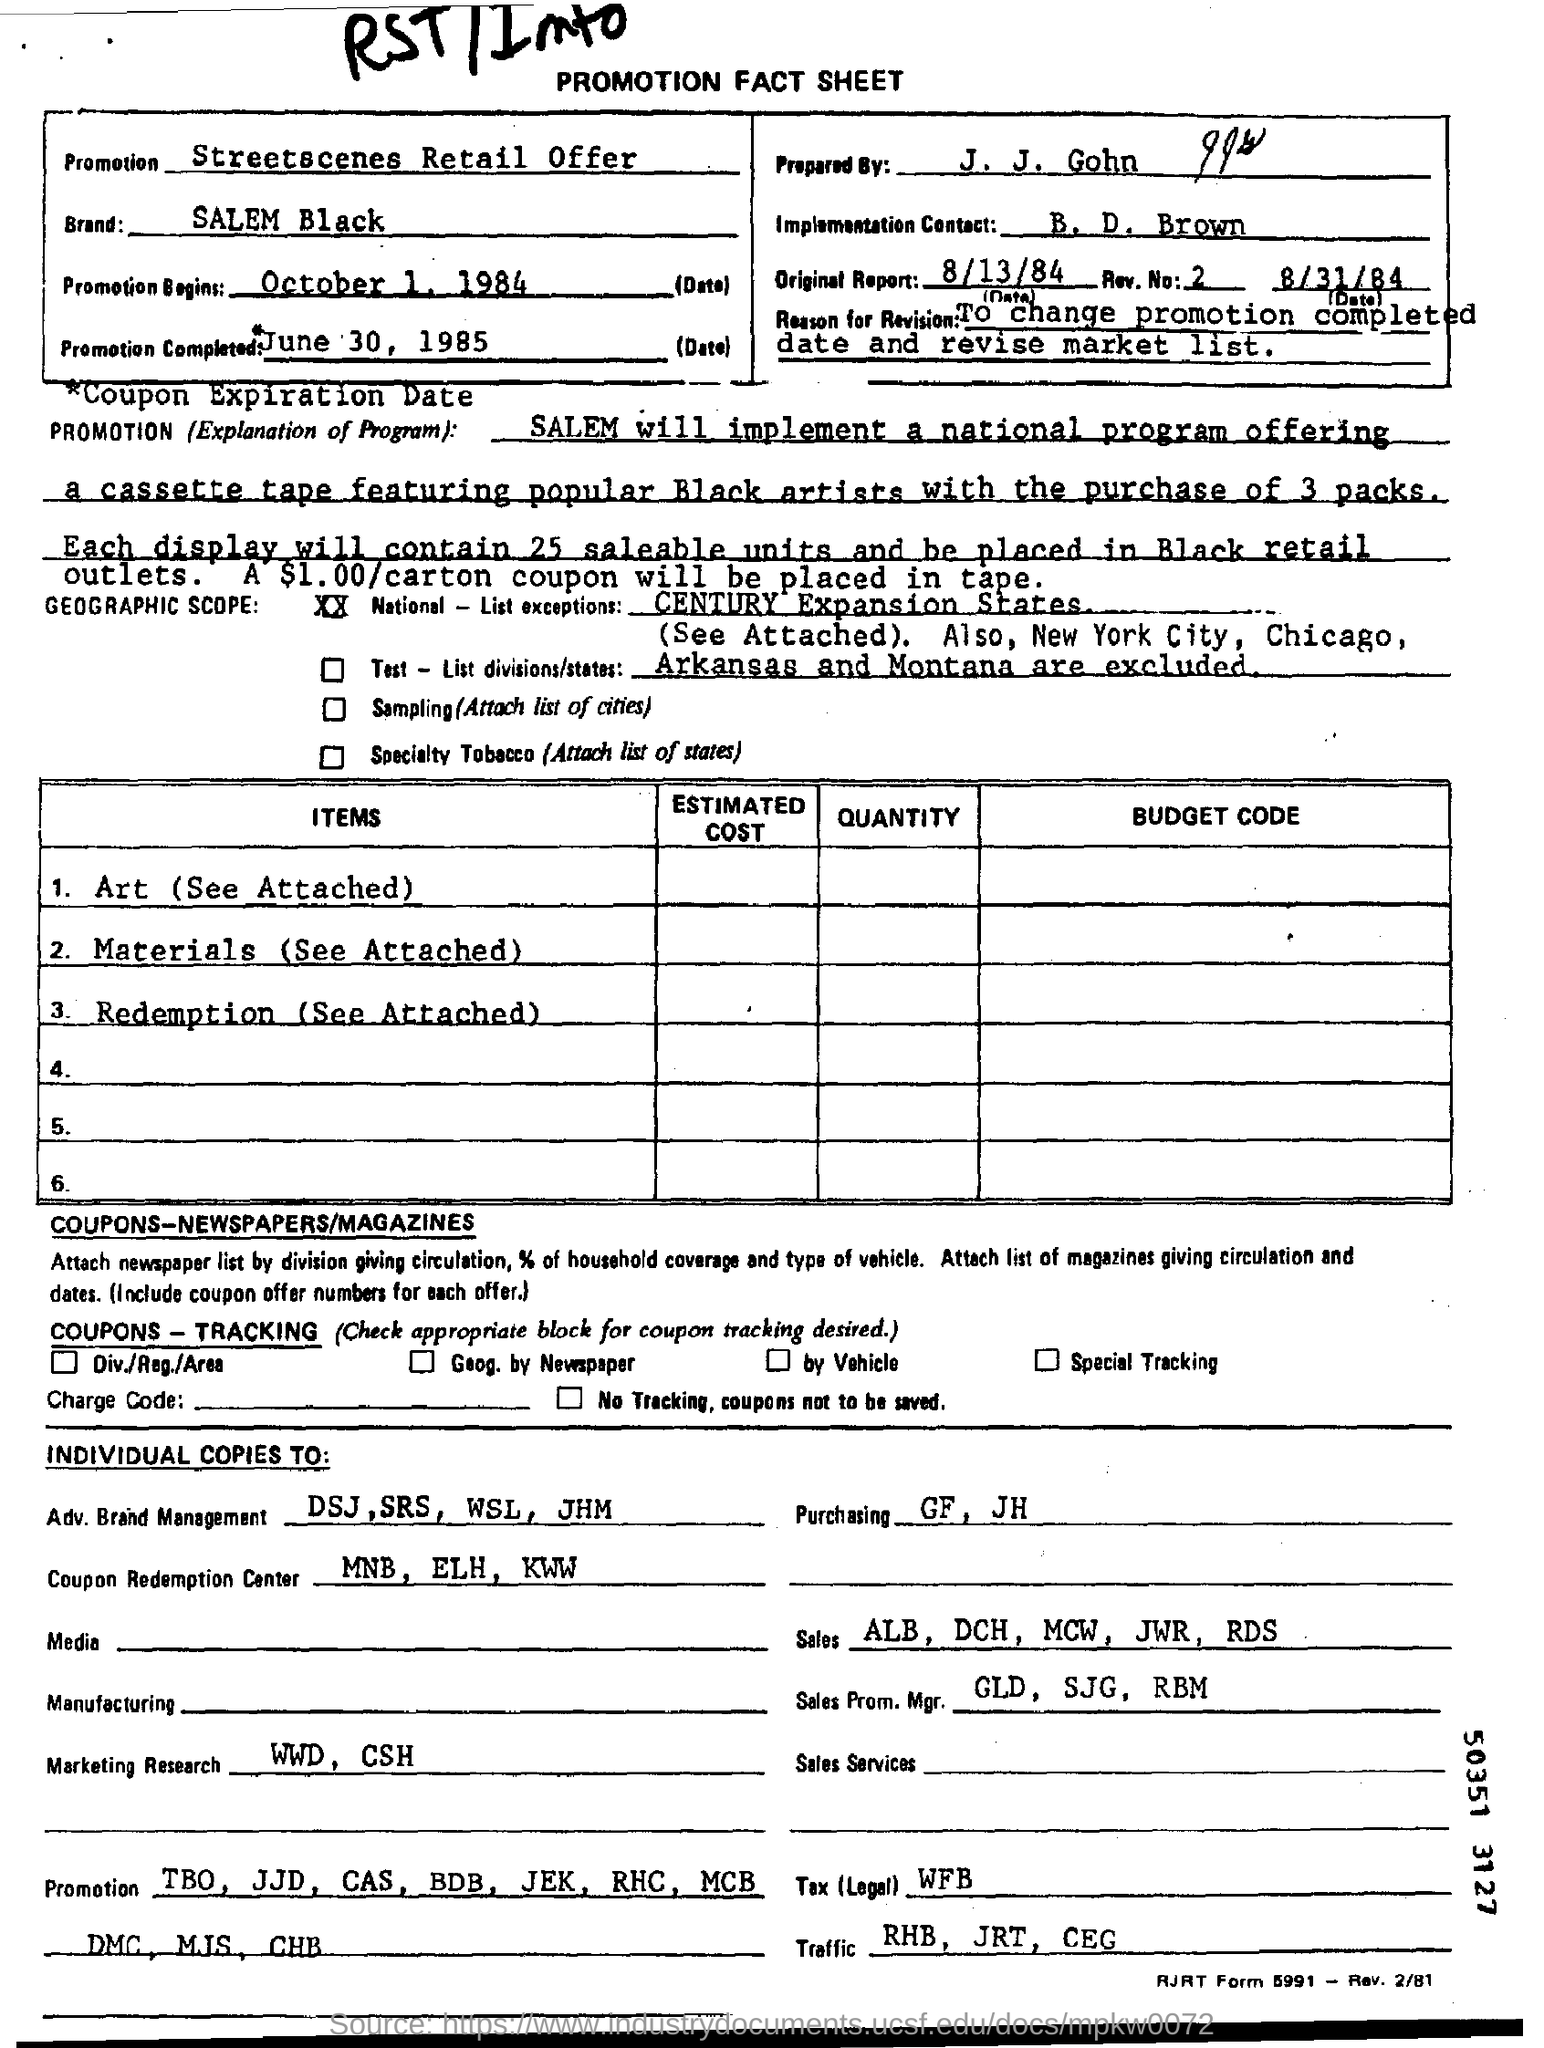What is written in the Letter Head ?
Ensure brevity in your answer.  PROMOTION FACT SHEET. What is written in the Promotion Field ?
Your response must be concise. Streetscenes Retail Offer. What is the Promotion Completed Date ?
Give a very brief answer. June 30, 1985. What is written in the Purchasing Field ?
Give a very brief answer. GF, JH. 